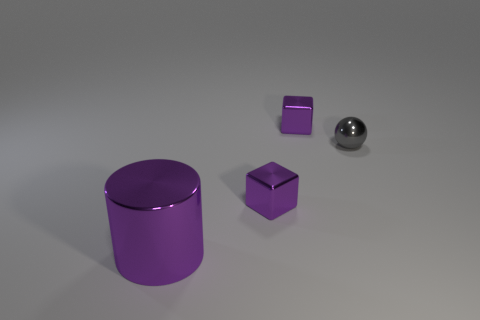What number of objects are tiny purple things or big purple things?
Give a very brief answer. 3. The large metallic thing in front of the block behind the gray shiny ball is what shape?
Keep it short and to the point. Cylinder. There is a small shiny thing behind the ball; is its shape the same as the gray metal thing?
Provide a succinct answer. No. What is the size of the purple cylinder that is made of the same material as the small gray ball?
Give a very brief answer. Large. What number of objects are either small cubes behind the purple cylinder or tiny purple metallic blocks that are in front of the small ball?
Provide a short and direct response. 2. Is the number of tiny purple metallic cubes in front of the large cylinder the same as the number of purple shiny blocks that are in front of the gray sphere?
Your answer should be very brief. No. Do the big metal thing and the small metallic object that is in front of the small gray metallic sphere have the same color?
Provide a short and direct response. Yes. Are there fewer large purple shiny blocks than big objects?
Offer a terse response. Yes. Do the shiny block that is behind the small metallic sphere and the big metal cylinder have the same color?
Offer a terse response. Yes. What number of purple cylinders have the same size as the shiny sphere?
Offer a terse response. 0. 